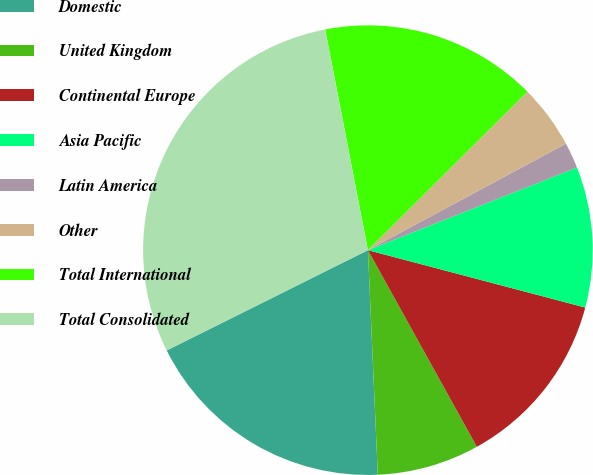<chart> <loc_0><loc_0><loc_500><loc_500><pie_chart><fcel>Domestic<fcel>United Kingdom<fcel>Continental Europe<fcel>Asia Pacific<fcel>Latin America<fcel>Other<fcel>Total International<fcel>Total Consolidated<nl><fcel>18.34%<fcel>7.35%<fcel>12.84%<fcel>10.1%<fcel>1.86%<fcel>4.6%<fcel>15.59%<fcel>29.32%<nl></chart> 